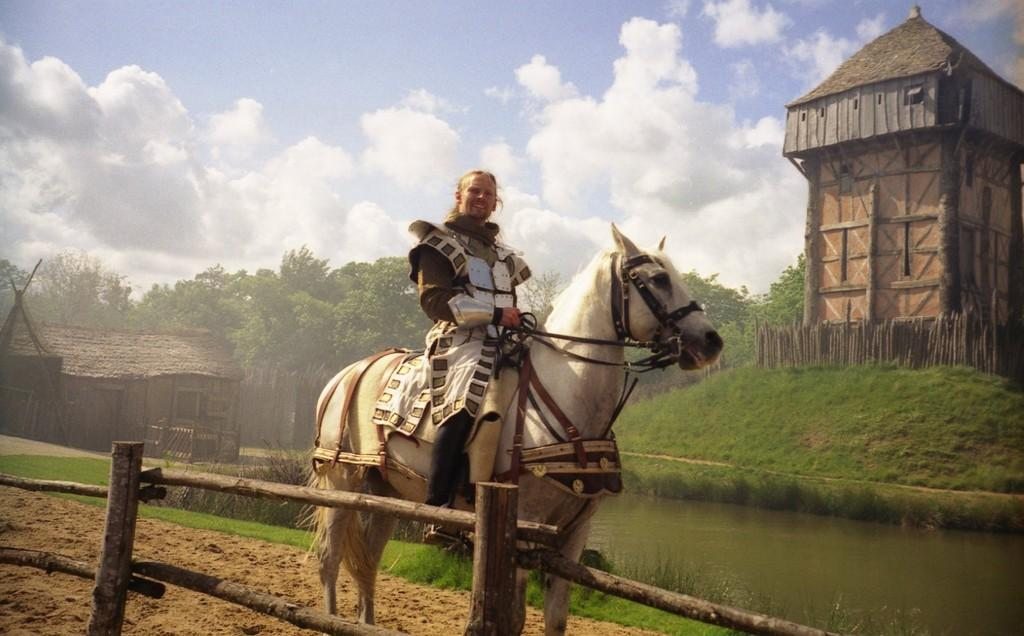What is the person in the image doing? The person is sitting on a horse in the image. What type of terrain can be seen in the image? There is grass, sand, and water visible in the image. What can be seen in the background of the image? There is a house, trees, and the sky visible in the background of the image. What is the condition of the sky in the image? The sky is visible in the background of the image, and there are clouds present. What love advice can be seen written on the horse's saddle in the image? There is no love advice or writing visible on the horse's saddle in the image. 